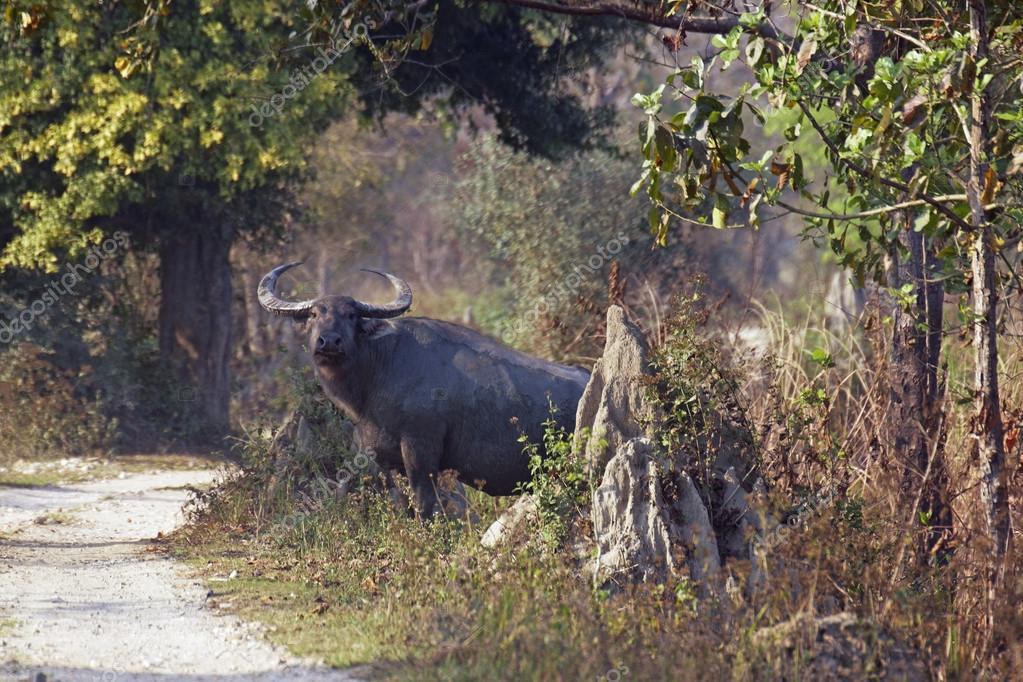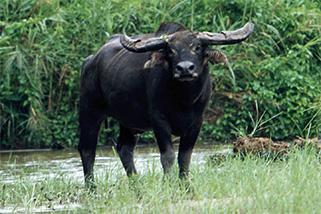The first image is the image on the left, the second image is the image on the right. Examine the images to the left and right. Is the description "Both images have only one dark bull each." accurate? Answer yes or no. Yes. The first image is the image on the left, the second image is the image on the right. Considering the images on both sides, is "There is only one bull facing left in the left image." valid? Answer yes or no. Yes. 